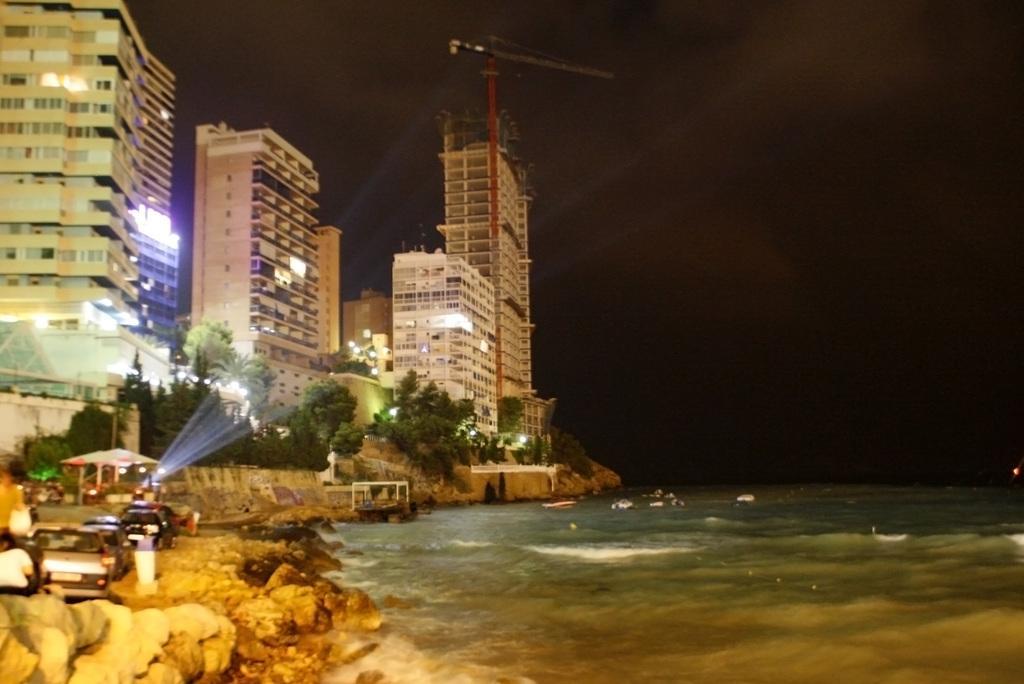Please provide a concise description of this image. This is the picture of a place where we have some buildings to the side and also we can see some vehicles and some water to the side. 